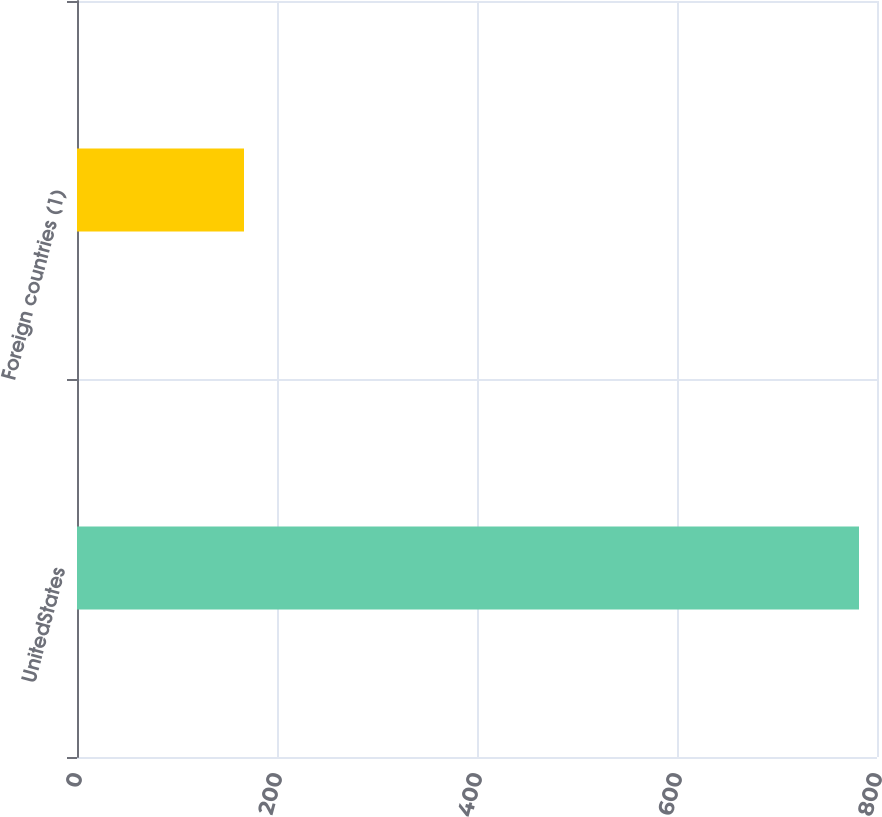Convert chart. <chart><loc_0><loc_0><loc_500><loc_500><bar_chart><fcel>UnitedStates<fcel>Foreign countries (1)<nl><fcel>782<fcel>167<nl></chart> 